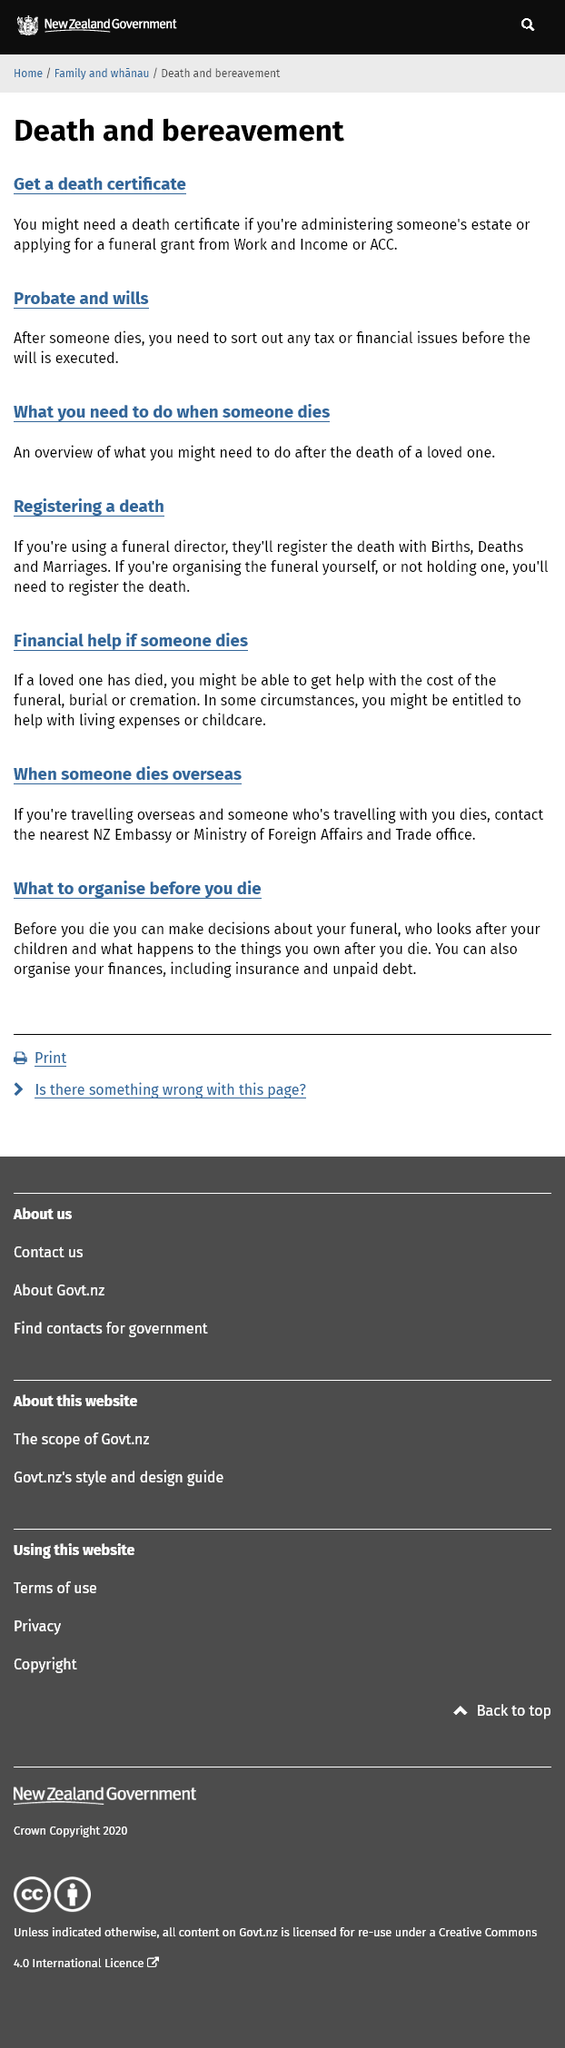Identify some key points in this picture. The funeral director will register the death with Births, Deaths, and Marriages by providing the necessary information and documentation. If you are administering someone's estate, you may need a death certificate in order to fulfill your duties. After someone dies, there are tax and financial issues that must be sorted out, such as probate and wills. 